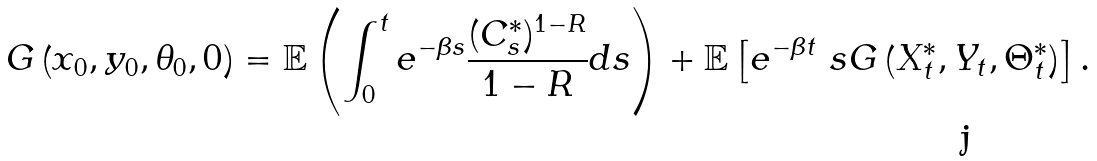<formula> <loc_0><loc_0><loc_500><loc_500>G \left ( x _ { 0 } , y _ { 0 } , \theta _ { 0 } , 0 \right ) = \mathbb { E } \left ( \int _ { 0 } ^ { t } e ^ { - \beta s } \frac { ( C ^ { * } _ { s } ) ^ { 1 - R } } { 1 - R } d s \right ) + \mathbb { E } \left [ e ^ { - \beta t } \ s G \left ( X ^ { * } _ { t } , Y _ { t } , \Theta ^ { * } _ { t } \right ) \right ] .</formula> 